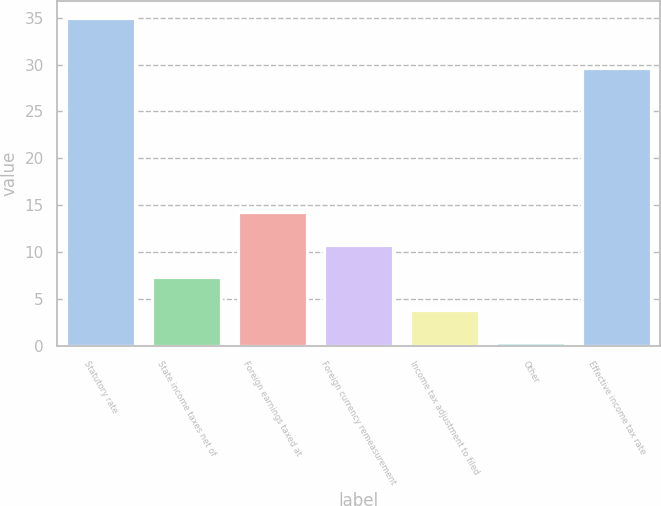<chart> <loc_0><loc_0><loc_500><loc_500><bar_chart><fcel>Statutory rate<fcel>State income taxes net of<fcel>Foreign earnings taxed at<fcel>Foreign currency remeasurement<fcel>Income tax adjustment to filed<fcel>Other<fcel>Effective income tax rate<nl><fcel>35<fcel>7.32<fcel>14.24<fcel>10.78<fcel>3.86<fcel>0.4<fcel>29.6<nl></chart> 